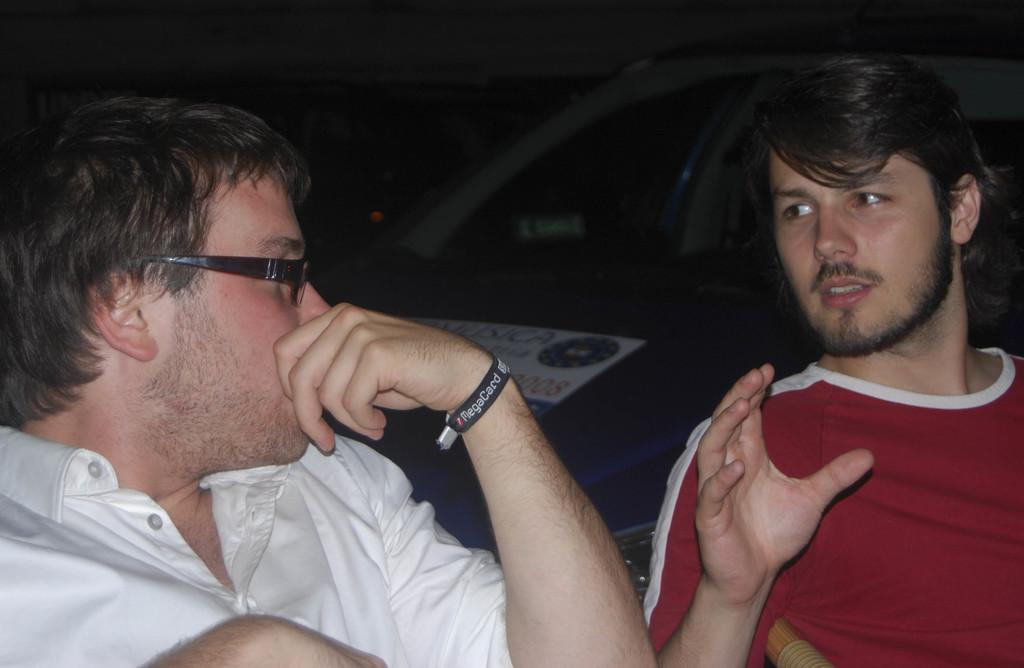How many people are in the image? There are two men in the image. What are the two men doing in the image? The two men are talking to each other. Can you describe one of the men's appearance? One of the men is wearing glasses. What type of ticket is the man holding in the image? There is no ticket present in the image; the two men are simply talking to each other. How does the snow affect the conversation between the two men in the image? There is no snow present in the image, so it does not affect the conversation between the two men. 